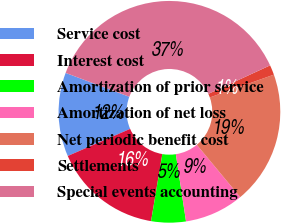Convert chart to OTSL. <chart><loc_0><loc_0><loc_500><loc_500><pie_chart><fcel>Service cost<fcel>Interest cost<fcel>Amortization of prior service<fcel>Amortization of net loss<fcel>Net periodic benefit cost<fcel>Settlements<fcel>Special events accounting<nl><fcel>12.23%<fcel>15.83%<fcel>5.04%<fcel>8.63%<fcel>19.42%<fcel>1.44%<fcel>37.41%<nl></chart> 